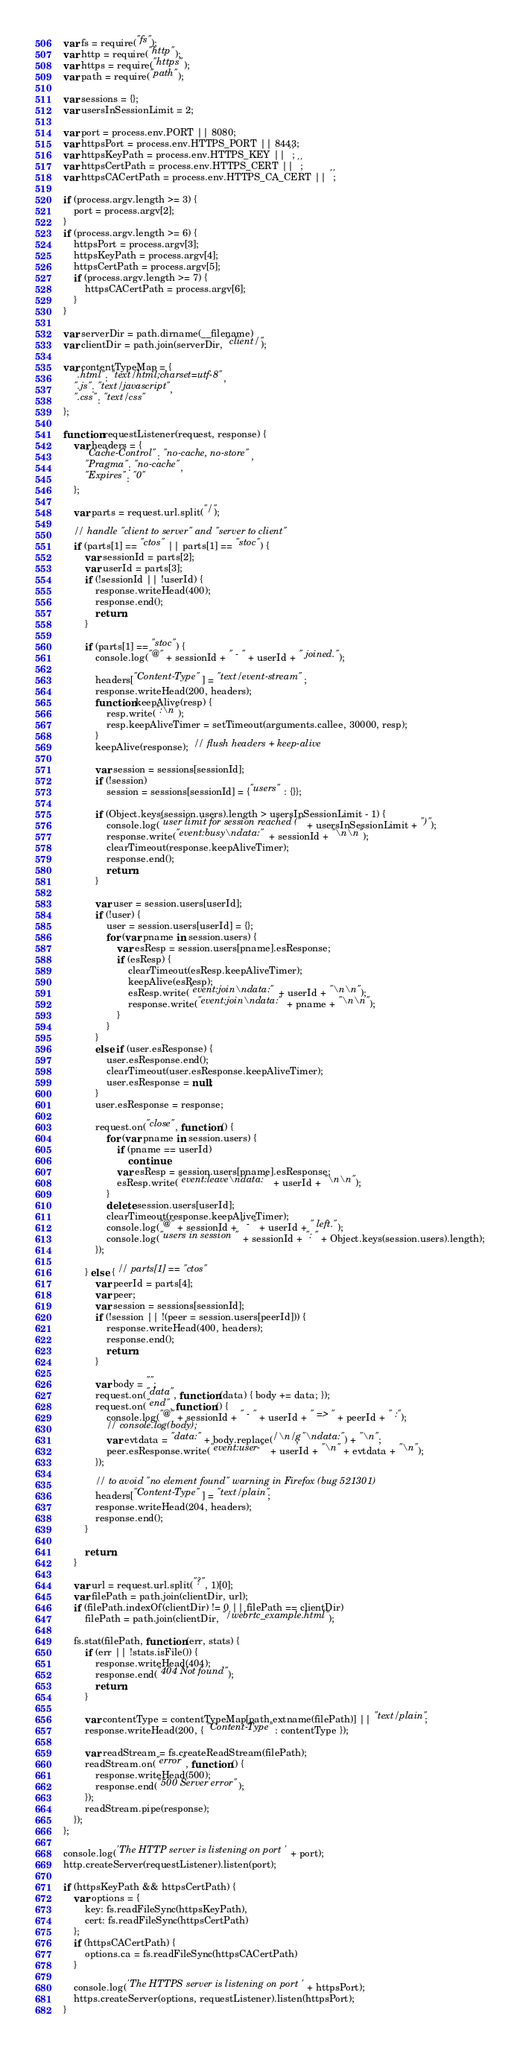<code> <loc_0><loc_0><loc_500><loc_500><_JavaScript_>var fs = require("fs");
var http = require("http");
var https = require("https");
var path = require("path");

var sessions = {};
var usersInSessionLimit = 2;

var port = process.env.PORT || 8080;
var httpsPort = process.env.HTTPS_PORT || 8443;
var httpsKeyPath = process.env.HTTPS_KEY || '';
var httpsCertPath = process.env.HTTPS_CERT || '';
var httpsCACertPath = process.env.HTTPS_CA_CERT || '';

if (process.argv.length >= 3) {
    port = process.argv[2];
}
if (process.argv.length >= 6) {
    httpsPort = process.argv[3];
    httpsKeyPath = process.argv[4];
    httpsCertPath = process.argv[5];
    if (process.argv.length >= 7) {
        httpsCACertPath = process.argv[6];
    }
}

var serverDir = path.dirname(__filename)
var clientDir = path.join(serverDir, "client/");

var contentTypeMap = {
    ".html": "text/html;charset=utf-8",
    ".js": "text/javascript",
    ".css": "text/css"
};

function requestListener(request, response) {
    var headers = {
        "Cache-Control": "no-cache, no-store",
        "Pragma": "no-cache",
        "Expires": "0"
    };

    var parts = request.url.split("/");

    // handle "client to server" and "server to client"
    if (parts[1] == "ctos" || parts[1] == "stoc") {
        var sessionId = parts[2];
        var userId = parts[3];
        if (!sessionId || !userId) {
            response.writeHead(400);
            response.end();
            return;
        }

        if (parts[1] == "stoc") {
            console.log("@" + sessionId + " - " + userId + " joined.");

            headers["Content-Type"] = "text/event-stream";
            response.writeHead(200, headers);
            function keepAlive(resp) {
                resp.write(":\n");
                resp.keepAliveTimer = setTimeout(arguments.callee, 30000, resp);
            }
            keepAlive(response);  // flush headers + keep-alive

            var session = sessions[sessionId];
            if (!session)
                session = sessions[sessionId] = {"users" : {}};

            if (Object.keys(session.users).length > usersInSessionLimit - 1) {
                console.log("user limit for session reached (" + usersInSessionLimit + ")");
                response.write("event:busy\ndata:" + sessionId + "\n\n");
                clearTimeout(response.keepAliveTimer);
                response.end();
                return;
            }

            var user = session.users[userId];
            if (!user) {
                user = session.users[userId] = {};
                for (var pname in session.users) {
                    var esResp = session.users[pname].esResponse;
                    if (esResp) {
                        clearTimeout(esResp.keepAliveTimer);
                        keepAlive(esResp);
                        esResp.write("event:join\ndata:" + userId + "\n\n");
                        response.write("event:join\ndata:" + pname + "\n\n");
                    }
                }
            }
            else if (user.esResponse) {
                user.esResponse.end();
                clearTimeout(user.esResponse.keepAliveTimer);
                user.esResponse = null;
            }
            user.esResponse = response;

            request.on("close", function () {
                for (var pname in session.users) {
                    if (pname == userId)
                        continue;
                    var esResp = session.users[pname].esResponse;
                    esResp.write("event:leave\ndata:" + userId + "\n\n");
                }
                delete session.users[userId];
                clearTimeout(response.keepAliveTimer);
                console.log("@" + sessionId + " - " + userId + " left.");
                console.log("users in session " + sessionId + ": " + Object.keys(session.users).length);
            });

        } else { // parts[1] == "ctos"
            var peerId = parts[4];
            var peer;
            var session = sessions[sessionId];
            if (!session || !(peer = session.users[peerId])) {
                response.writeHead(400, headers);
                response.end();
                return;
            }

            var body = "";
            request.on("data", function (data) { body += data; });
            request.on("end", function () {
                console.log("@" + sessionId + " - " + userId + " => " + peerId + " :");
                // console.log(body);
                var evtdata = "data:" + body.replace(/\n/g, "\ndata:") + "\n";
                peer.esResponse.write("event:user-" + userId + "\n" + evtdata + "\n");
            });

            // to avoid "no element found" warning in Firefox (bug 521301)
            headers["Content-Type"] = "text/plain";
            response.writeHead(204, headers);
            response.end();
        }

        return;
    }

    var url = request.url.split("?", 1)[0];
    var filePath = path.join(clientDir, url);
    if (filePath.indexOf(clientDir) != 0 || filePath == clientDir)
        filePath = path.join(clientDir, "/webrtc_example.html");

    fs.stat(filePath, function (err, stats) {
        if (err || !stats.isFile()) {
            response.writeHead(404);
            response.end("404 Not found");
            return;
        }

        var contentType = contentTypeMap[path.extname(filePath)] || "text/plain";
        response.writeHead(200, { "Content-Type": contentType });

        var readStream = fs.createReadStream(filePath);
        readStream.on("error", function () {
            response.writeHead(500);
            response.end("500 Server error");
        });
        readStream.pipe(response);
    });
};

console.log('The HTTP server is listening on port ' + port);
http.createServer(requestListener).listen(port);

if (httpsKeyPath && httpsCertPath) {
    var options = {
        key: fs.readFileSync(httpsKeyPath),
        cert: fs.readFileSync(httpsCertPath)
    };
    if (httpsCACertPath) {
        options.ca = fs.readFileSync(httpsCACertPath)
    }

    console.log('The HTTPS server is listening on port ' + httpsPort);
    https.createServer(options, requestListener).listen(httpsPort);
}
</code> 